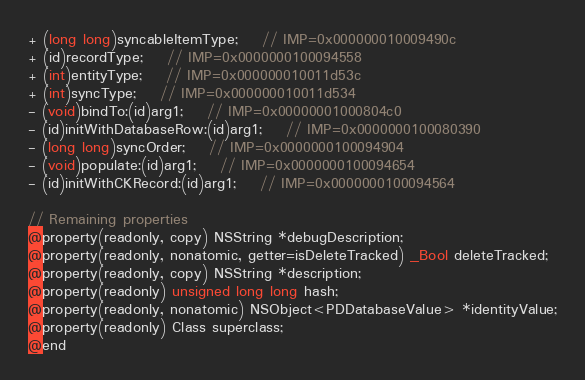Convert code to text. <code><loc_0><loc_0><loc_500><loc_500><_C_>+ (long long)syncableItemType;	// IMP=0x000000010009490c
+ (id)recordType;	// IMP=0x0000000100094558
+ (int)entityType;	// IMP=0x000000010011d53c
+ (int)syncType;	// IMP=0x000000010011d534
- (void)bindTo:(id)arg1;	// IMP=0x00000001000804c0
- (id)initWithDatabaseRow:(id)arg1;	// IMP=0x0000000100080390
- (long long)syncOrder;	// IMP=0x0000000100094904
- (void)populate:(id)arg1;	// IMP=0x0000000100094654
- (id)initWithCKRecord:(id)arg1;	// IMP=0x0000000100094564

// Remaining properties
@property(readonly, copy) NSString *debugDescription;
@property(readonly, nonatomic, getter=isDeleteTracked) _Bool deleteTracked;
@property(readonly, copy) NSString *description;
@property(readonly) unsigned long long hash;
@property(readonly, nonatomic) NSObject<PDDatabaseValue> *identityValue;
@property(readonly) Class superclass;
@end

</code> 